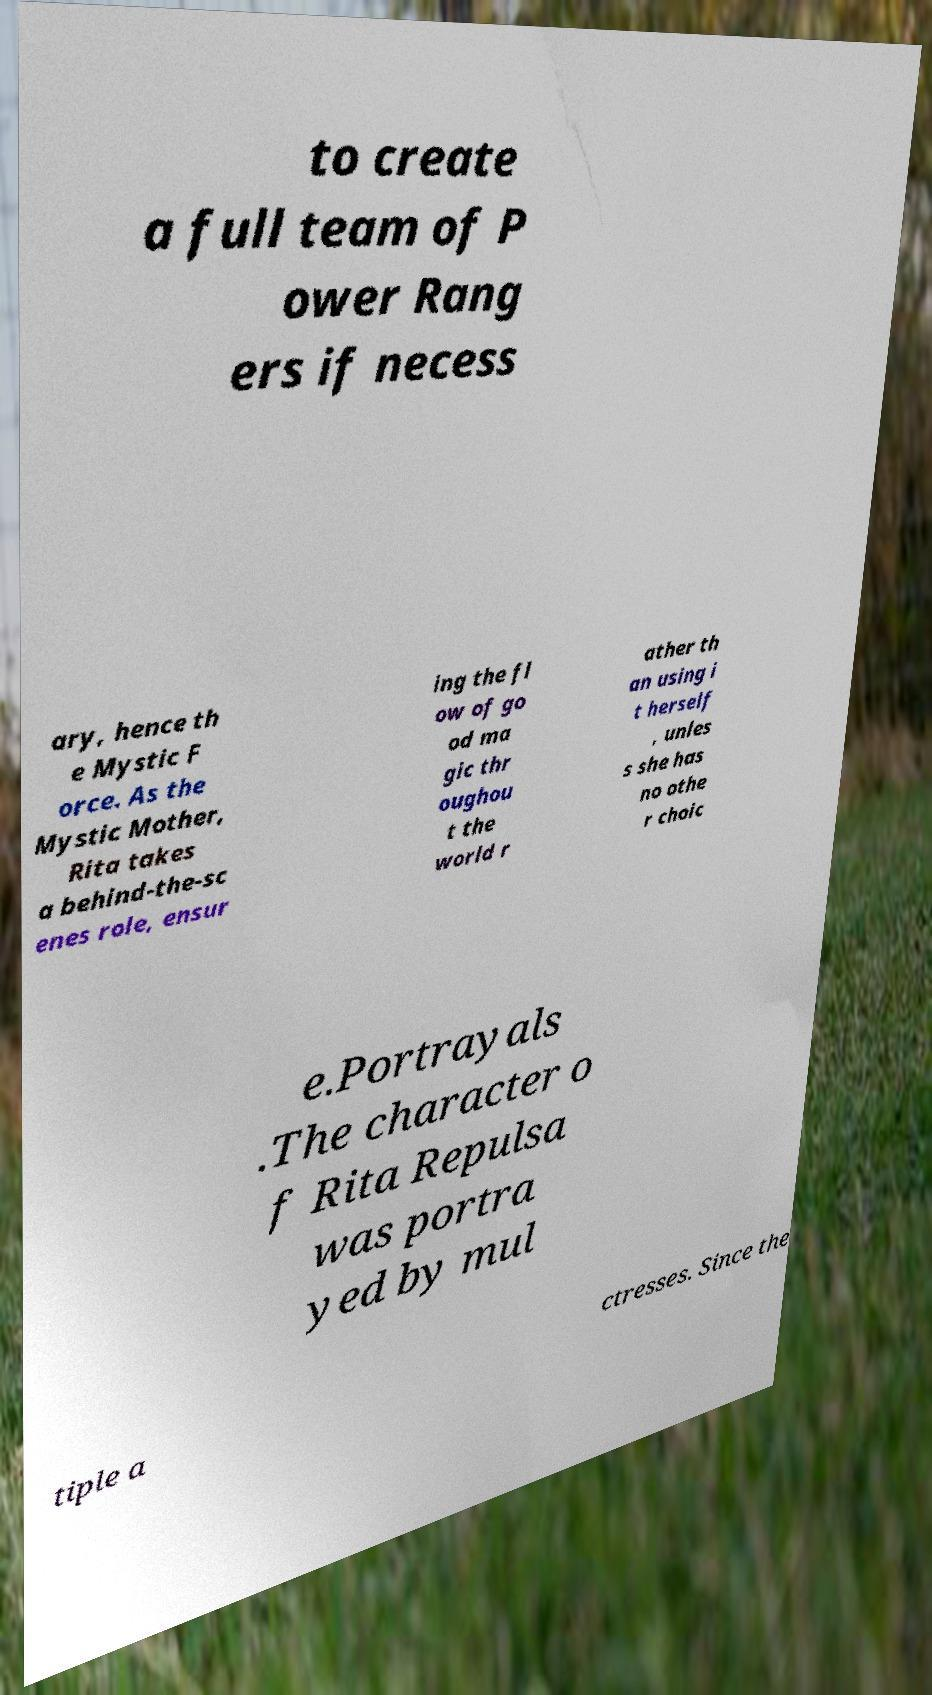Please identify and transcribe the text found in this image. to create a full team of P ower Rang ers if necess ary, hence th e Mystic F orce. As the Mystic Mother, Rita takes a behind-the-sc enes role, ensur ing the fl ow of go od ma gic thr oughou t the world r ather th an using i t herself , unles s she has no othe r choic e.Portrayals .The character o f Rita Repulsa was portra yed by mul tiple a ctresses. Since the 